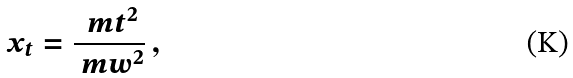<formula> <loc_0><loc_0><loc_500><loc_500>x _ { t } = \frac { \ m t ^ { 2 } } { \ m w ^ { 2 } } \, ,</formula> 